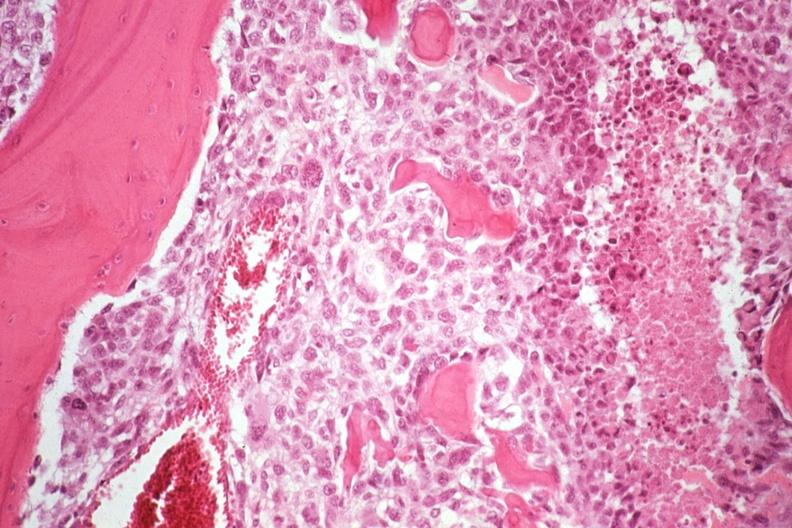what is present?
Answer the question using a single word or phrase. Joints 